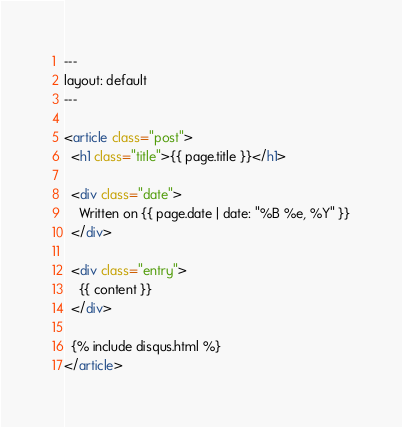<code> <loc_0><loc_0><loc_500><loc_500><_HTML_>---
layout: default
---

<article class="post">
  <h1 class="title">{{ page.title }}</h1>

  <div class="date">
    Written on {{ page.date | date: "%B %e, %Y" }}
  </div>

  <div class="entry">
    {{ content }}
  </div>

  {% include disqus.html %}
</article>
</code> 